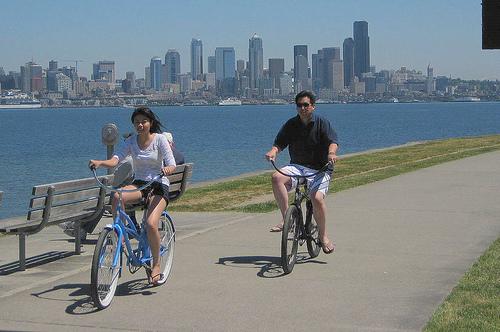How many bikes are there?
Give a very brief answer. 2. Are these bikers wearing shirts?
Answer briefly. Yes. What kind of shoes are the bike riders wearing?
Answer briefly. Flip flops. How many bicycles?
Write a very short answer. 2. What is to the right of the road?
Concise answer only. Grass. Which leg supports the bicycle?
Short answer required. Both. Did one of the bikes fall down?
Keep it brief. No. What is the woman doing while riding her bicycle?
Write a very short answer. Smiling. How many people are riding bikes?
Keep it brief. 2. Can this machine be used for transportation, like a bicycle or unicycle?
Short answer required. Yes. Are both bikes locked up?
Keep it brief. No. Are there palm trees?
Be succinct. No. What material is the bench made out of?
Concise answer only. Wood. How many types of vehicles with wheels are shown?
Concise answer only. 1. Is this woman wearing tight shorts?
Short answer required. Yes. Are the bikers racing?
Quick response, please. No. Is the girl biking alone?
Concise answer only. No. What kind of shoes does the man wear?
Quick response, please. Flip flops. Are they parking the cycle?
Write a very short answer. No. How many bikes can be seen?
Concise answer only. 2. Are the people near water?
Short answer required. Yes. Are they in a city?
Concise answer only. Yes. 